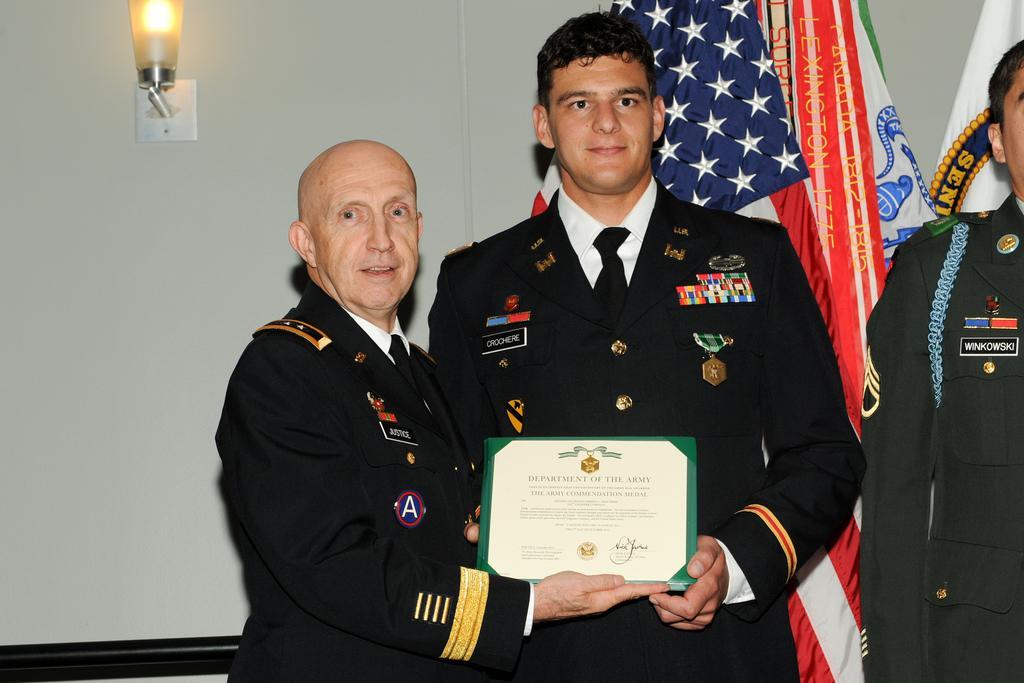Can you describe this image briefly? In the middle of the image two persons are standing and holding a frame. Behind them there are some flags and there is a wall. On the wall there is a light. 